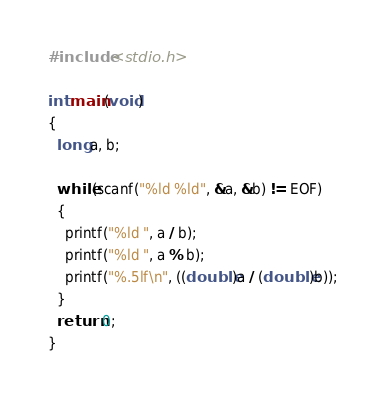Convert code to text. <code><loc_0><loc_0><loc_500><loc_500><_C_>#include <stdio.h>
 
int main(void)
{
  long a, b;
 
  while(scanf("%ld %ld", &a, &b) != EOF)
  {
    printf("%ld ", a / b);
    printf("%ld ", a % b);
    printf("%.5lf\n", ((double)a / (double)b));
  }
  return 0;
}</code> 